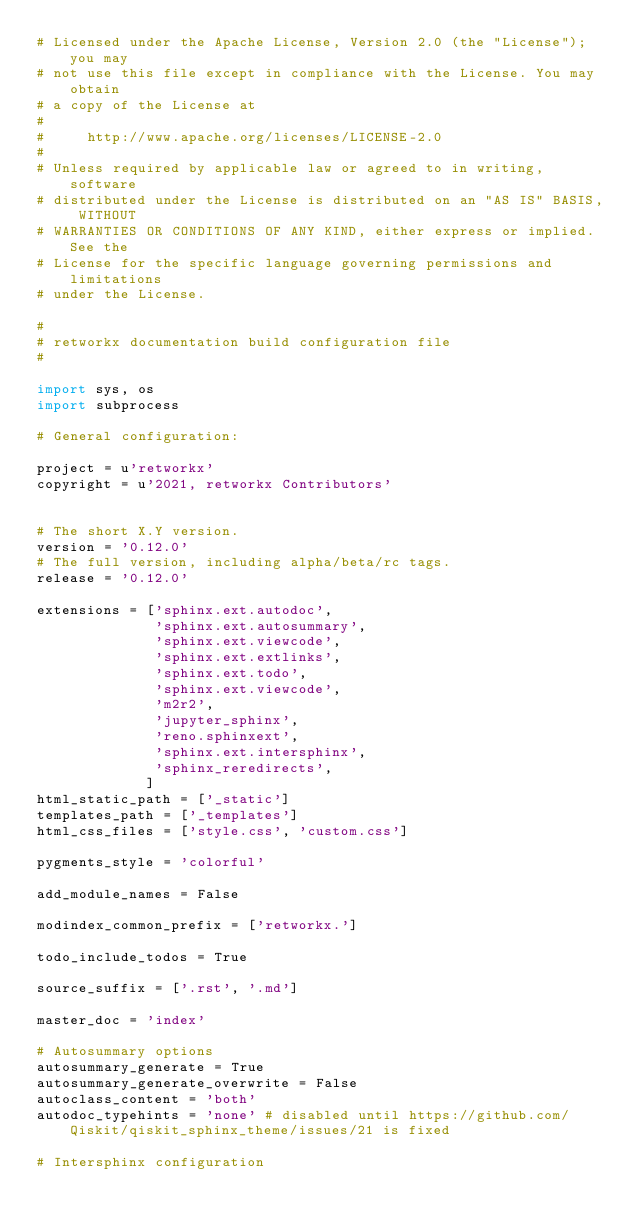<code> <loc_0><loc_0><loc_500><loc_500><_Python_># Licensed under the Apache License, Version 2.0 (the "License"); you may
# not use this file except in compliance with the License. You may obtain
# a copy of the License at
#
#     http://www.apache.org/licenses/LICENSE-2.0
#
# Unless required by applicable law or agreed to in writing, software
# distributed under the License is distributed on an "AS IS" BASIS, WITHOUT
# WARRANTIES OR CONDITIONS OF ANY KIND, either express or implied. See the
# License for the specific language governing permissions and limitations
# under the License.

#
# retworkx documentation build configuration file
#

import sys, os
import subprocess

# General configuration:

project = u'retworkx'
copyright = u'2021, retworkx Contributors'


# The short X.Y version.
version = '0.12.0'
# The full version, including alpha/beta/rc tags.
release = '0.12.0'

extensions = ['sphinx.ext.autodoc',
              'sphinx.ext.autosummary',
              'sphinx.ext.viewcode',
              'sphinx.ext.extlinks',
              'sphinx.ext.todo',
              'sphinx.ext.viewcode',
              'm2r2',
              'jupyter_sphinx',
              'reno.sphinxext',
              'sphinx.ext.intersphinx',
              'sphinx_reredirects',
             ]
html_static_path = ['_static']
templates_path = ['_templates']
html_css_files = ['style.css', 'custom.css']

pygments_style = 'colorful'

add_module_names = False

modindex_common_prefix = ['retworkx.']

todo_include_todos = True

source_suffix = ['.rst', '.md']

master_doc = 'index'

# Autosummary options
autosummary_generate = True
autosummary_generate_overwrite = False
autoclass_content = 'both'
autodoc_typehints = 'none' # disabled until https://github.com/Qiskit/qiskit_sphinx_theme/issues/21 is fixed

# Intersphinx configuration</code> 